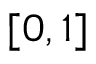<formula> <loc_0><loc_0><loc_500><loc_500>[ 0 , 1 ]</formula> 